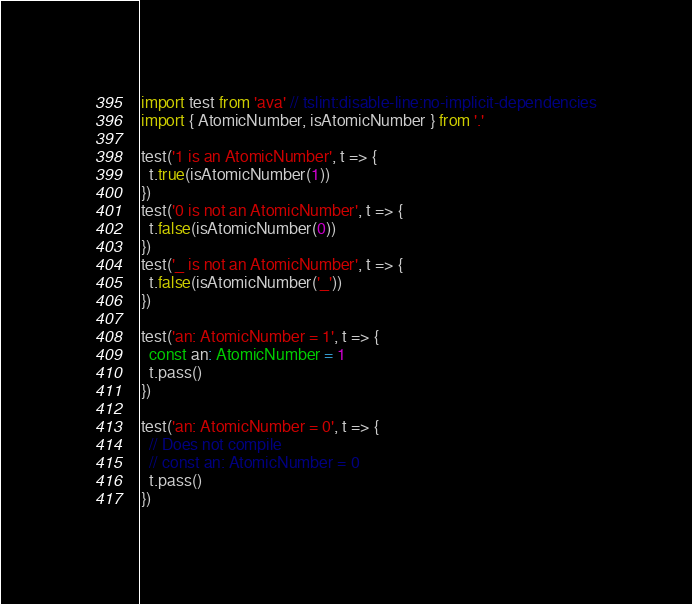<code> <loc_0><loc_0><loc_500><loc_500><_TypeScript_>import test from 'ava' // tslint:disable-line:no-implicit-dependencies
import { AtomicNumber, isAtomicNumber } from '.'

test('1 is an AtomicNumber', t => {
  t.true(isAtomicNumber(1))
})
test('0 is not an AtomicNumber', t => {
  t.false(isAtomicNumber(0))
})
test('_ is not an AtomicNumber', t => {
  t.false(isAtomicNumber('_'))
})

test('an: AtomicNumber = 1', t => {
  const an: AtomicNumber = 1
  t.pass()
})

test('an: AtomicNumber = 0', t => {
  // Does not compile
  // const an: AtomicNumber = 0
  t.pass()
})
</code> 